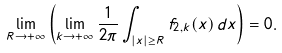Convert formula to latex. <formula><loc_0><loc_0><loc_500><loc_500>\lim _ { R \to + \infty } \left ( \lim _ { k \to + \infty } \frac { 1 } { 2 \pi } \int _ { | x | \geq R } f _ { 2 , k } ( x ) \, d x \right ) = 0 .</formula> 